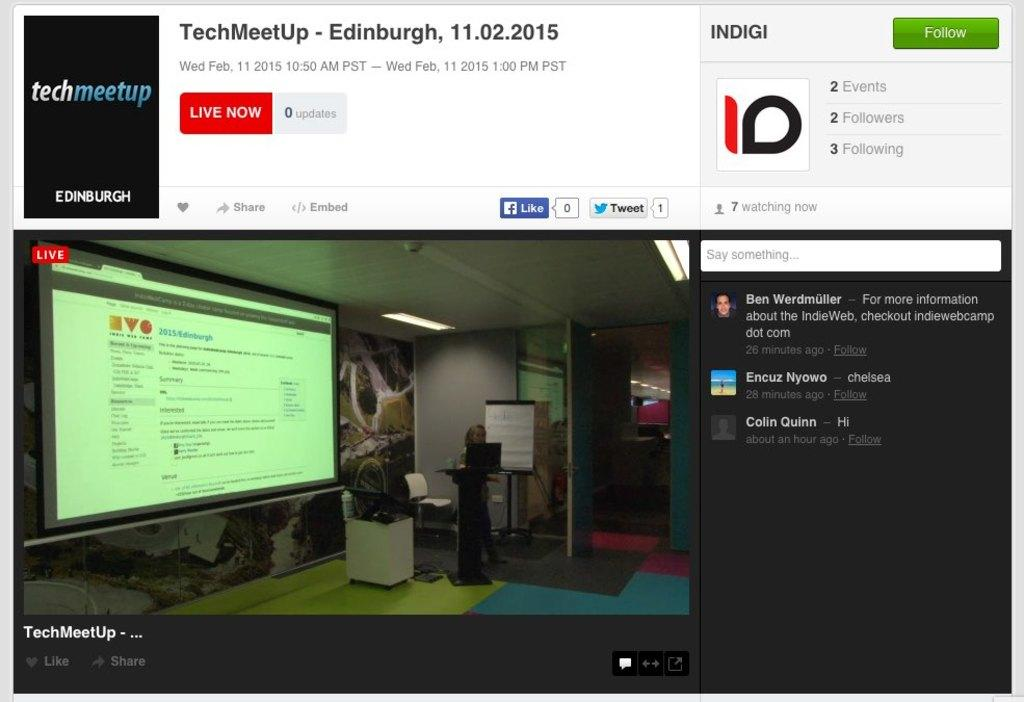<image>
Offer a succinct explanation of the picture presented. Screen monitor showing a techmeetup for people streaming. 